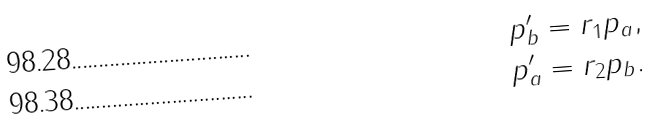<formula> <loc_0><loc_0><loc_500><loc_500>p _ { b } ^ { \prime } & = r _ { 1 } p _ { a } , \\ p _ { a } ^ { \prime } & = r _ { 2 } p _ { b } .</formula> 